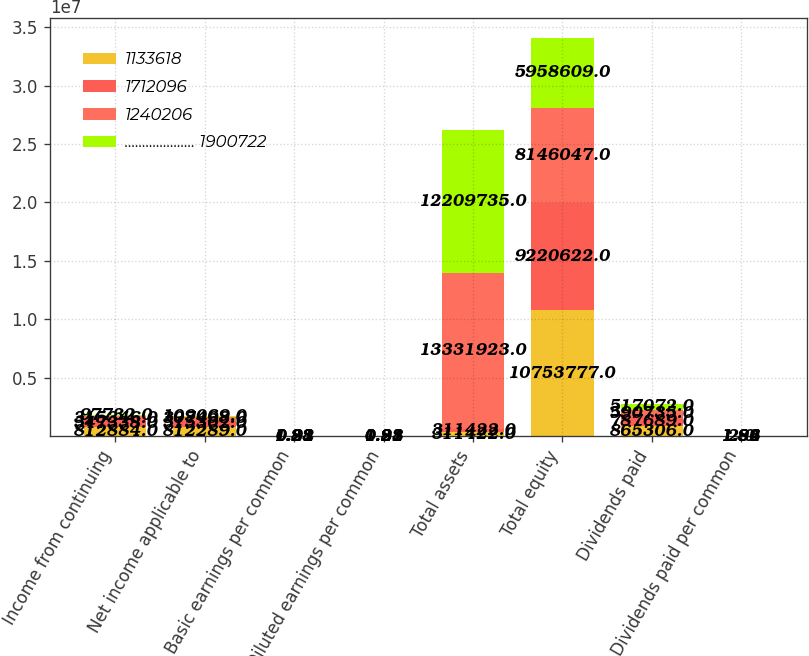Convert chart. <chart><loc_0><loc_0><loc_500><loc_500><stacked_bar_chart><ecel><fcel>Income from continuing<fcel>Net income applicable to<fcel>Basic earnings per common<fcel>Diluted earnings per common<fcel>Total assets<fcel>Total equity<fcel>Dividends paid<fcel>Dividends paid per common<nl><fcel>1133618<fcel>812884<fcel>812289<fcel>1.83<fcel>1.83<fcel>311422<fcel>1.07538e+07<fcel>865306<fcel>2<nl><fcel>1712096<fcel>547338<fcel>515302<fcel>1.28<fcel>1.28<fcel>311422<fcel>9.22062e+06<fcel>787689<fcel>1.92<nl><fcel>1240206<fcel>315346<fcel>307498<fcel>0.91<fcel>0.91<fcel>1.33319e+07<fcel>8.14605e+06<fcel>590735<fcel>1.86<nl><fcel>.................... 1900722<fcel>97732<fcel>109069<fcel>0.22<fcel>0.22<fcel>1.22097e+07<fcel>5.95861e+06<fcel>517072<fcel>1.84<nl></chart> 